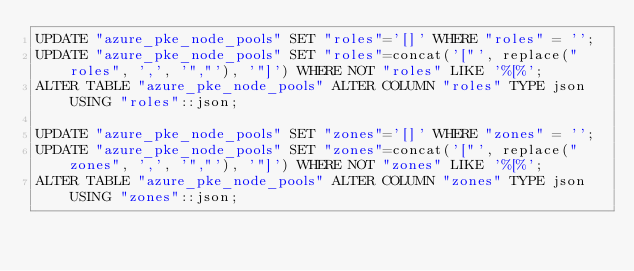Convert code to text. <code><loc_0><loc_0><loc_500><loc_500><_SQL_>UPDATE "azure_pke_node_pools" SET "roles"='[]' WHERE "roles" = '';
UPDATE "azure_pke_node_pools" SET "roles"=concat('["', replace("roles", ',', '","'), '"]') WHERE NOT "roles" LIKE '%[%';
ALTER TABLE "azure_pke_node_pools" ALTER COLUMN "roles" TYPE json USING "roles"::json;

UPDATE "azure_pke_node_pools" SET "zones"='[]' WHERE "zones" = '';
UPDATE "azure_pke_node_pools" SET "zones"=concat('["', replace("zones", ',', '","'), '"]') WHERE NOT "zones" LIKE '%[%';
ALTER TABLE "azure_pke_node_pools" ALTER COLUMN "zones" TYPE json USING "zones"::json;
</code> 